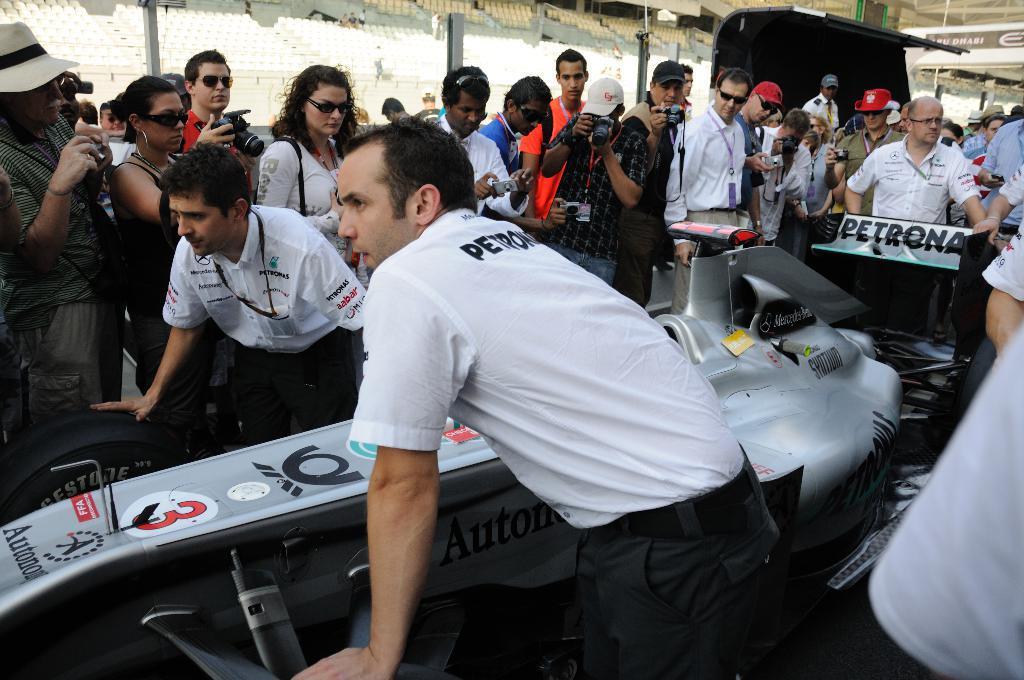In one or two sentences, can you explain what this image depicts? In this image we can see many people. Some are wearing caps. Some are wearing goggles. Some are holding cameras. There is a car. In the back there are chairs. 